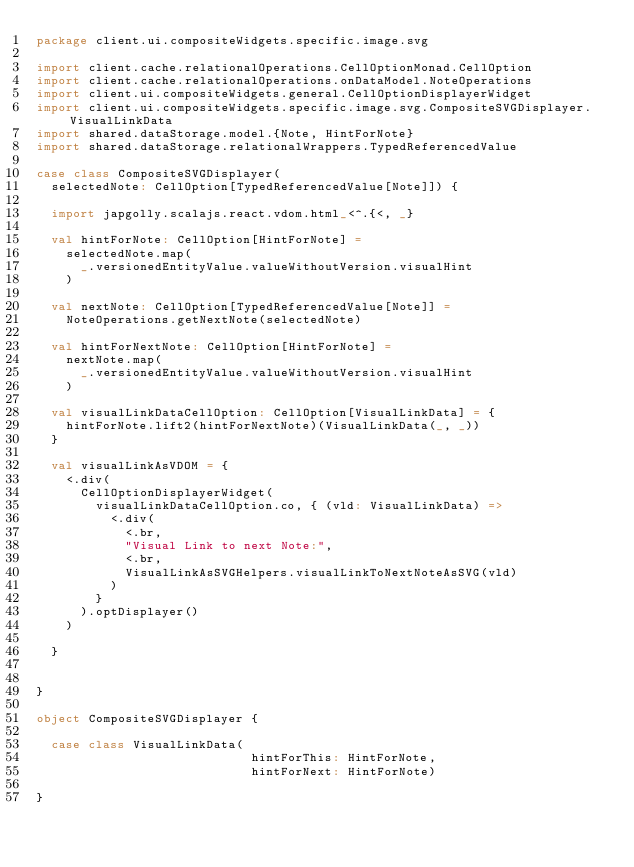Convert code to text. <code><loc_0><loc_0><loc_500><loc_500><_Scala_>package client.ui.compositeWidgets.specific.image.svg

import client.cache.relationalOperations.CellOptionMonad.CellOption
import client.cache.relationalOperations.onDataModel.NoteOperations
import client.ui.compositeWidgets.general.CellOptionDisplayerWidget
import client.ui.compositeWidgets.specific.image.svg.CompositeSVGDisplayer.VisualLinkData
import shared.dataStorage.model.{Note, HintForNote}
import shared.dataStorage.relationalWrappers.TypedReferencedValue

case class CompositeSVGDisplayer(
  selectedNote: CellOption[TypedReferencedValue[Note]]) {

  import japgolly.scalajs.react.vdom.html_<^.{<, _}

  val hintForNote: CellOption[HintForNote] =
    selectedNote.map(
      _.versionedEntityValue.valueWithoutVersion.visualHint
    )

  val nextNote: CellOption[TypedReferencedValue[Note]] =
    NoteOperations.getNextNote(selectedNote)

  val hintForNextNote: CellOption[HintForNote] =
    nextNote.map(
      _.versionedEntityValue.valueWithoutVersion.visualHint
    )

  val visualLinkDataCellOption: CellOption[VisualLinkData] = {
    hintForNote.lift2(hintForNextNote)(VisualLinkData(_, _))
  }

  val visualLinkAsVDOM = {
    <.div(
      CellOptionDisplayerWidget(
        visualLinkDataCellOption.co, { (vld: VisualLinkData) =>
          <.div(
            <.br,
            "Visual Link to next Note:",
            <.br,
            VisualLinkAsSVGHelpers.visualLinkToNextNoteAsSVG(vld)
          )
        }
      ).optDisplayer()
    )

  }


}

object CompositeSVGDisplayer {

  case class VisualLinkData(
                             hintForThis: HintForNote,
                             hintForNext: HintForNote)

}
</code> 